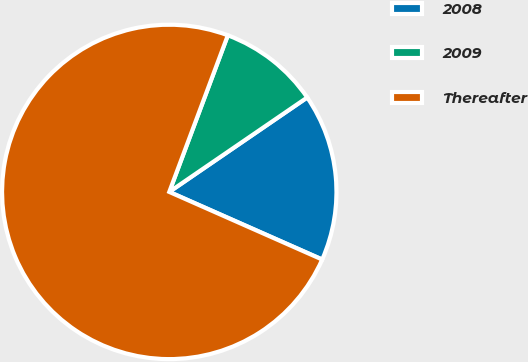<chart> <loc_0><loc_0><loc_500><loc_500><pie_chart><fcel>2008<fcel>2009<fcel>Thereafter<nl><fcel>16.18%<fcel>9.75%<fcel>74.07%<nl></chart> 